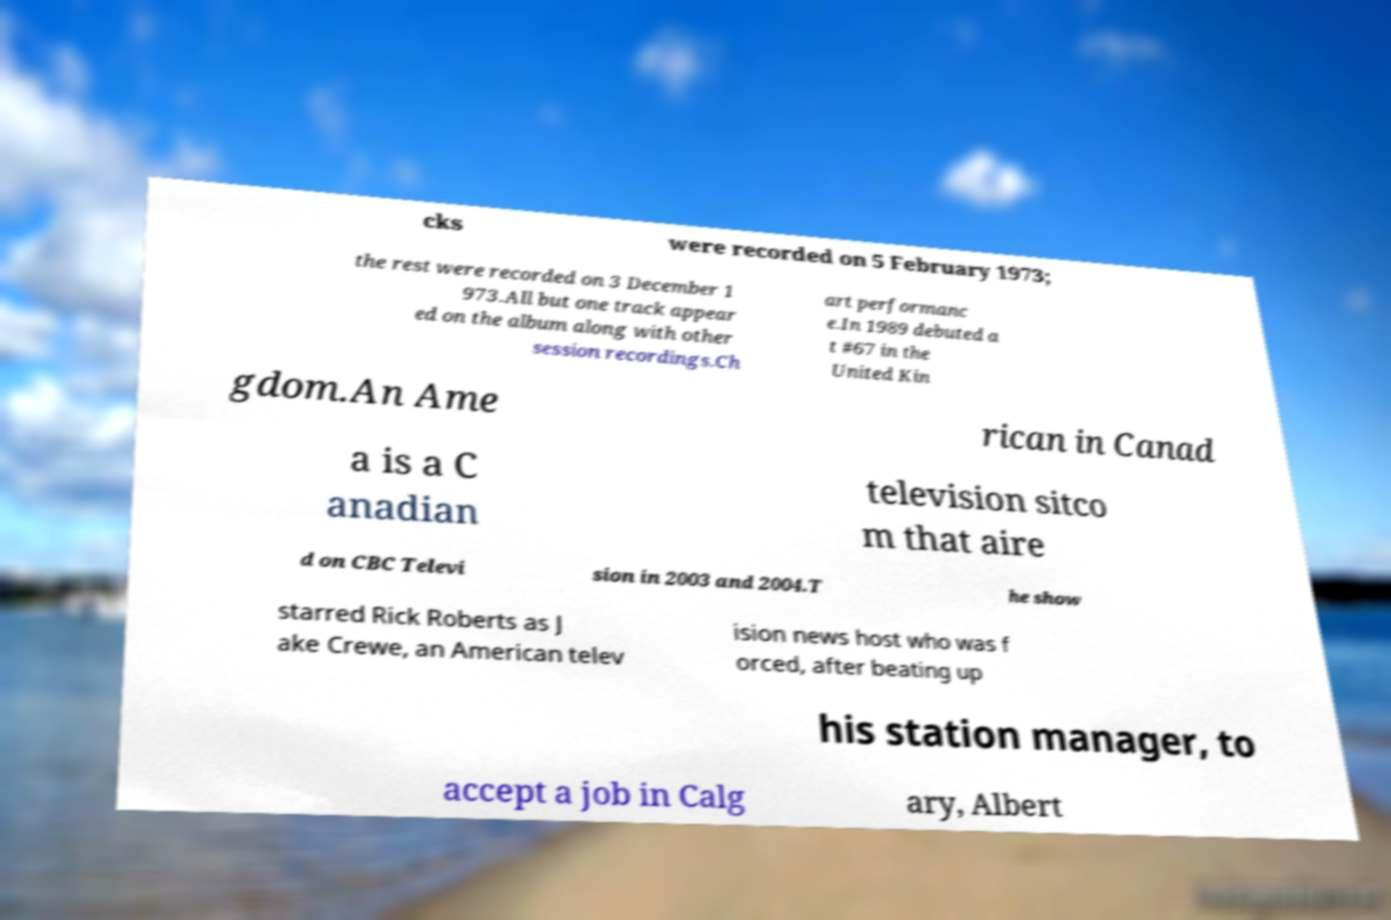Could you assist in decoding the text presented in this image and type it out clearly? cks were recorded on 5 February 1973; the rest were recorded on 3 December 1 973.All but one track appear ed on the album along with other session recordings.Ch art performanc e.In 1989 debuted a t #67 in the United Kin gdom.An Ame rican in Canad a is a C anadian television sitco m that aire d on CBC Televi sion in 2003 and 2004.T he show starred Rick Roberts as J ake Crewe, an American telev ision news host who was f orced, after beating up his station manager, to accept a job in Calg ary, Albert 